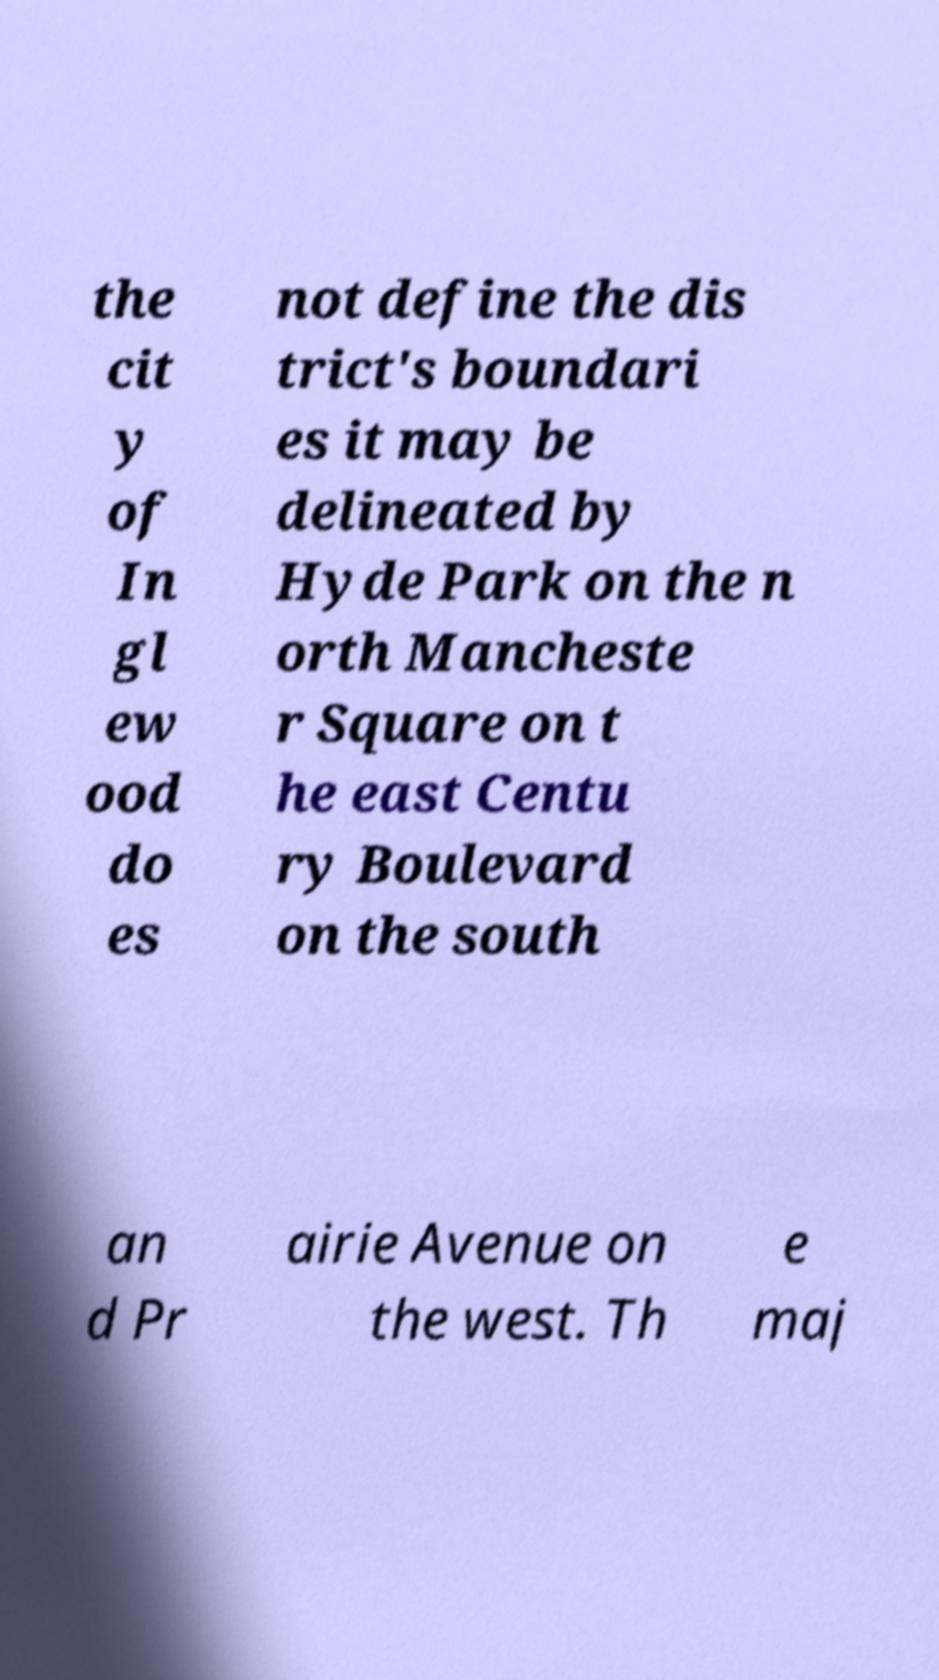Please identify and transcribe the text found in this image. the cit y of In gl ew ood do es not define the dis trict's boundari es it may be delineated by Hyde Park on the n orth Mancheste r Square on t he east Centu ry Boulevard on the south an d Pr airie Avenue on the west. Th e maj 